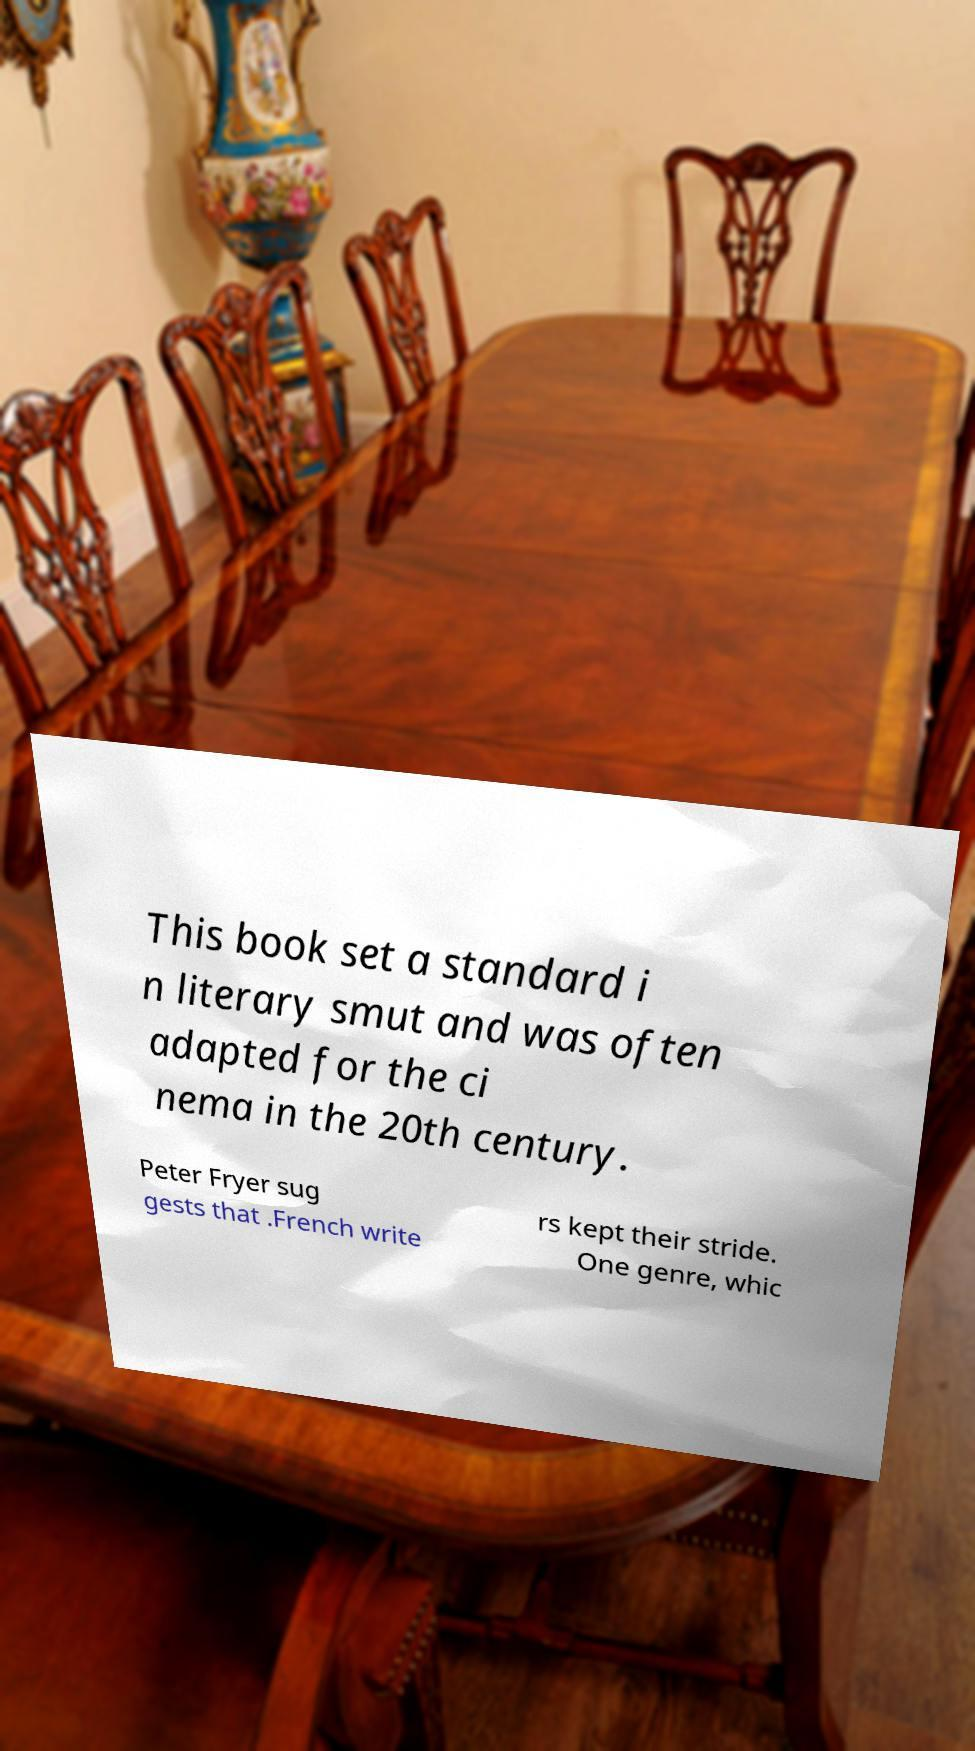Could you extract and type out the text from this image? This book set a standard i n literary smut and was often adapted for the ci nema in the 20th century. Peter Fryer sug gests that .French write rs kept their stride. One genre, whic 